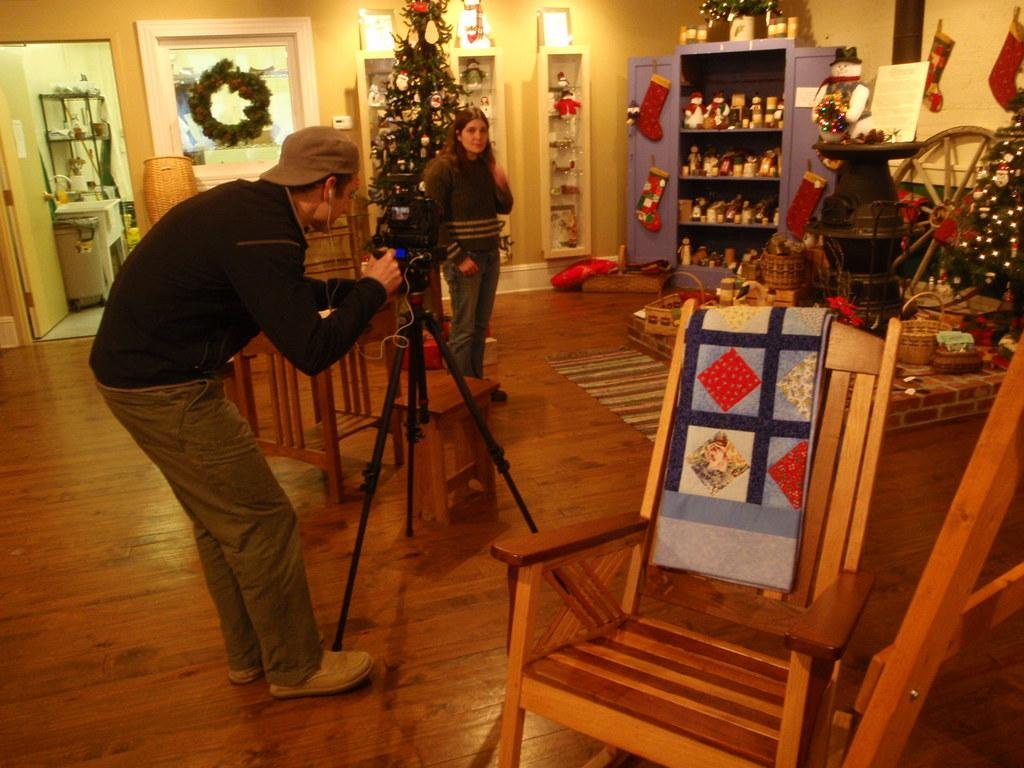What type of structure can be seen in the image? There is a wall in the image. What else can be seen in the image besides the wall? There is a rack, two people standing, a camera, and a chair visible in the image. What might the people be using the rack for? The rack could be used for hanging or storing items. What is the purpose of the camera in the image? The camera might be used for taking pictures or recording. What type of can is being used by one of the people in the image? There is no can present in the image; it only shows a wall, a rack, two people, a camera, and a chair. 